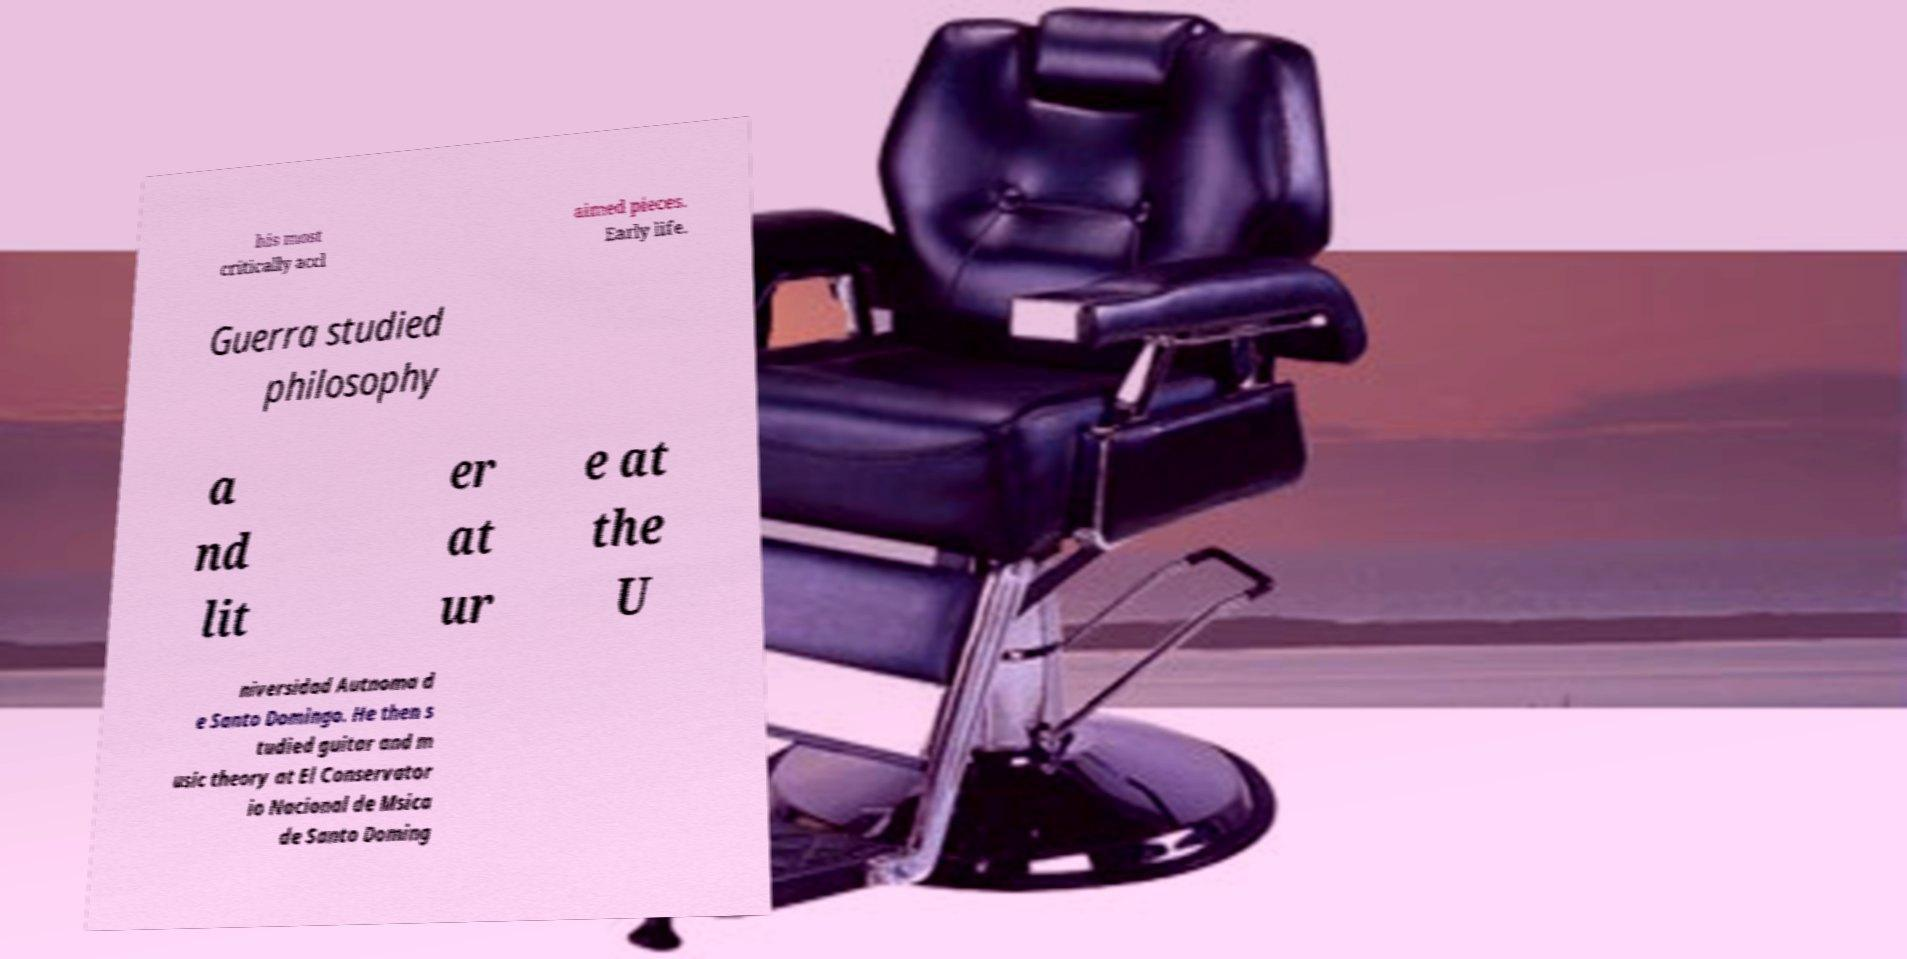Could you extract and type out the text from this image? his most critically accl aimed pieces. Early life. Guerra studied philosophy a nd lit er at ur e at the U niversidad Autnoma d e Santo Domingo. He then s tudied guitar and m usic theory at El Conservator io Nacional de Msica de Santo Doming 